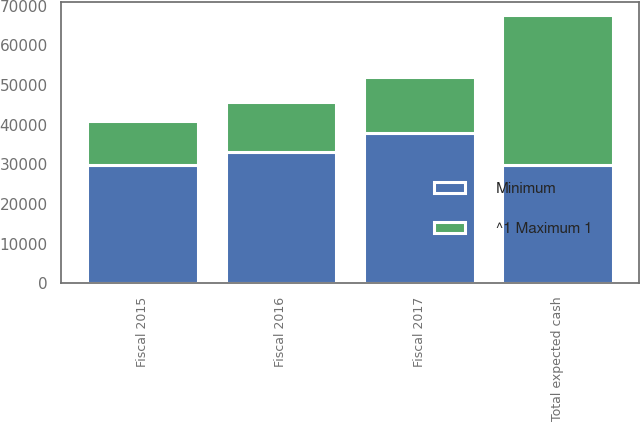Convert chart. <chart><loc_0><loc_0><loc_500><loc_500><stacked_bar_chart><ecel><fcel>Fiscal 2015<fcel>Fiscal 2016<fcel>Fiscal 2017<fcel>Total expected cash<nl><fcel>^1 Maximum 1<fcel>11191<fcel>12439<fcel>14179<fcel>37809<nl><fcel>Minimum<fcel>29843<fcel>33172<fcel>37811<fcel>29843<nl></chart> 